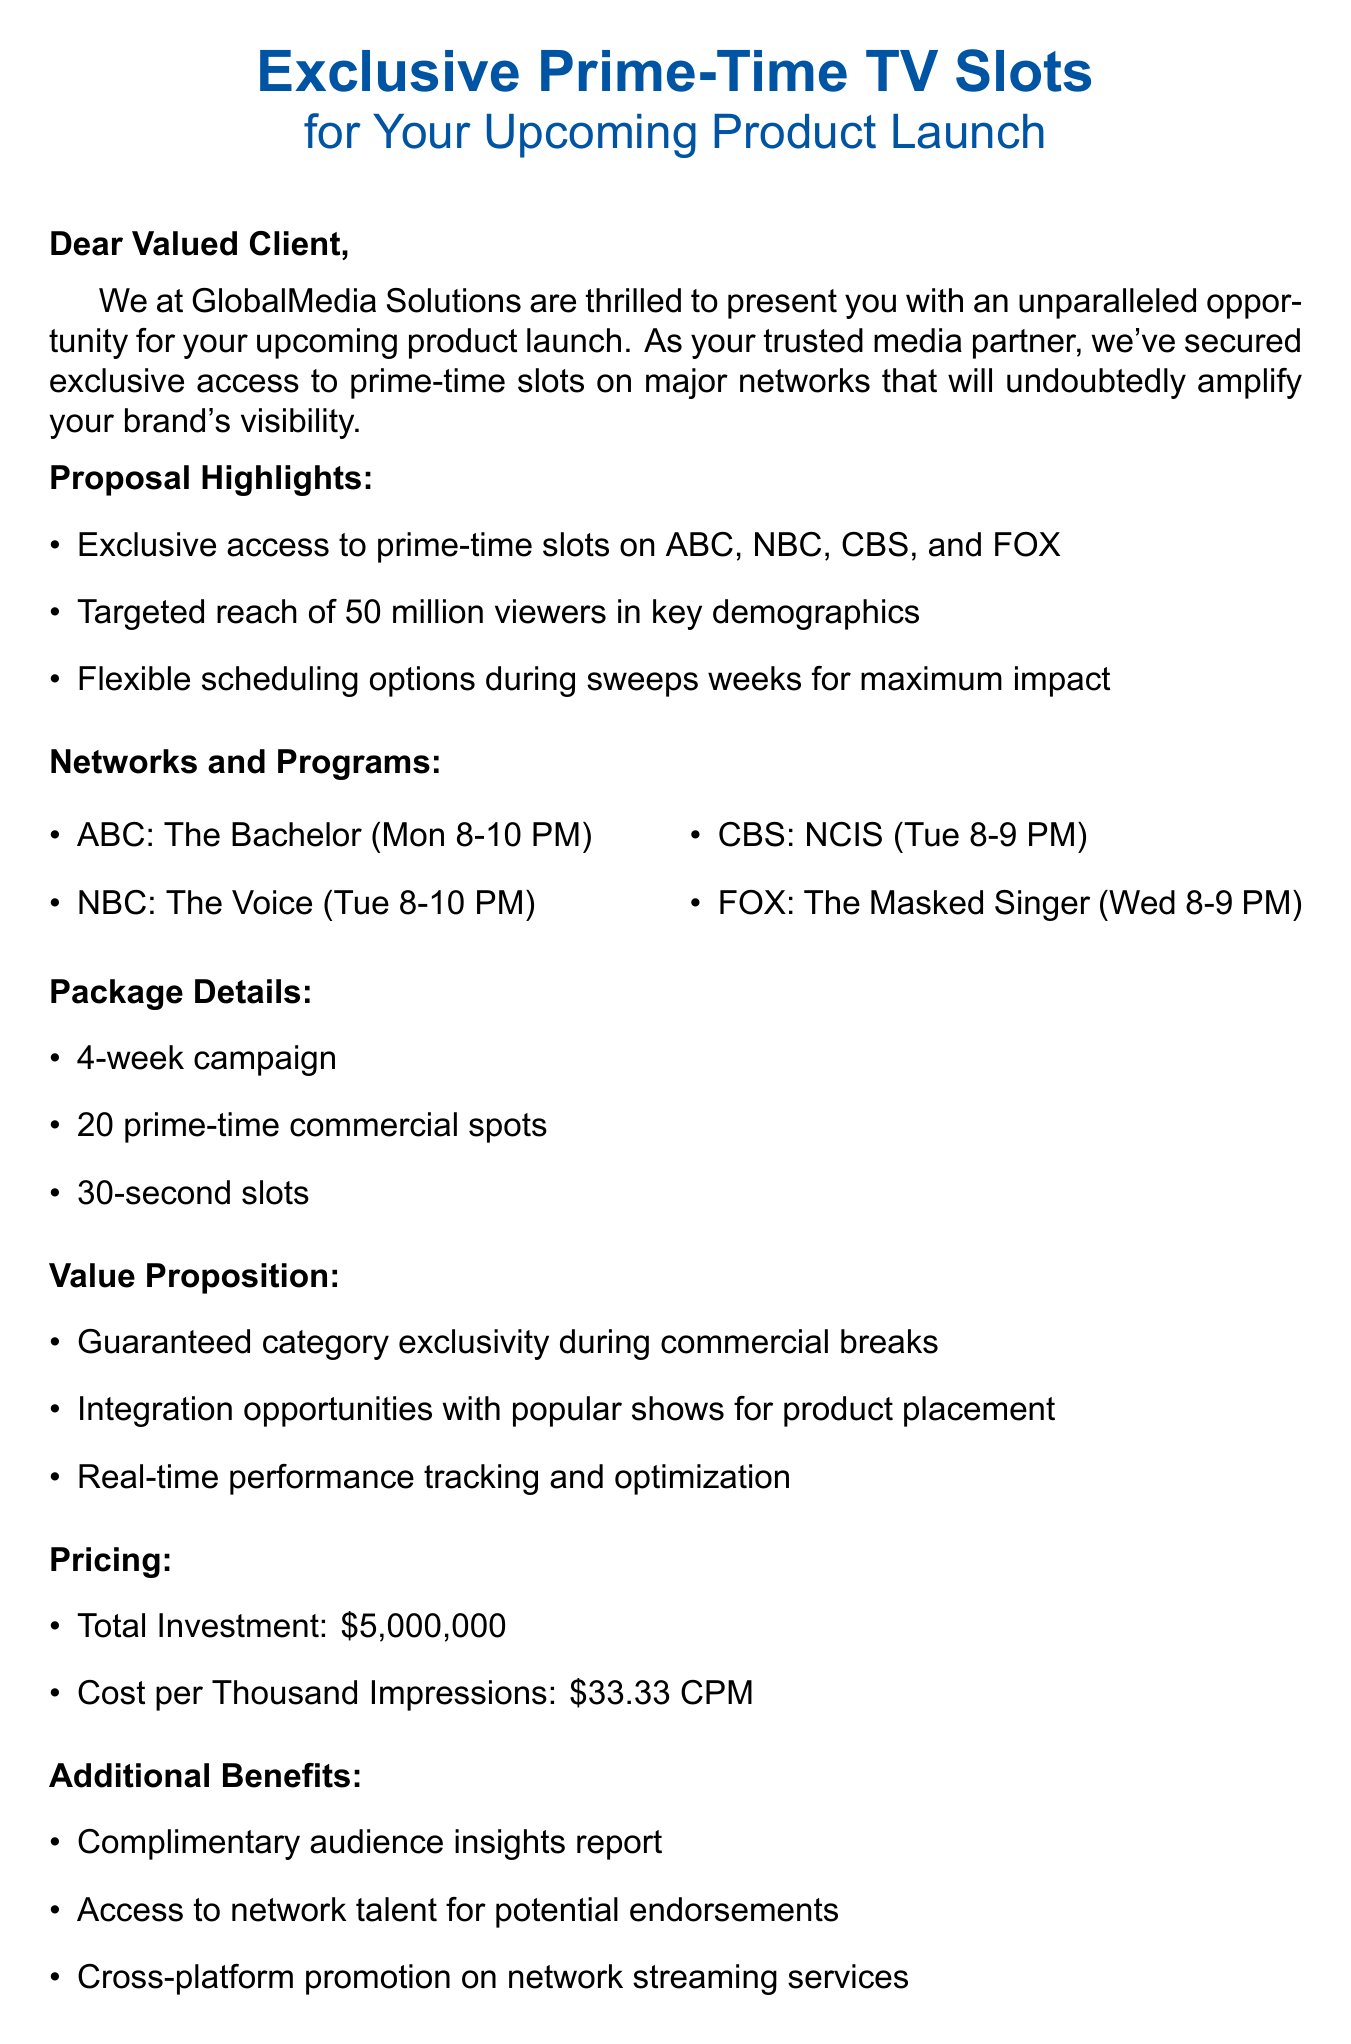What is the total investment? The total investment is stated in the pricing section of the document, which is $5,000,000.
Answer: $5,000,000 How many commercial spots are included in the package? The package details specify the total number of commercial spots, which is 20.
Answer: 20 Which network features "The Bachelor"? The networks and programs section lists the programs along with their respective networks, where "The Bachelor" is on ABC.
Answer: ABC What is the duration of the campaign? The package details mention that the duration of the campaign is 4 weeks.
Answer: 4-week campaign What is the cost per thousand impressions (CPM)? The pricing section provides the cost per thousand impressions, which is $33.33 CPM.
Answer: $33.33 CPM What type of report is included as an additional benefit? The additional benefits section mentions a complimentary audience insights report.
Answer: Complimentary audience insights report Which program airs on NBC? The networks and programs section states that "The Voice" airs on NBC.
Answer: The Voice How many prime-time networks are mentioned in the proposal? The proposal highlights indicate that there are four major networks mentioned: ABC, NBC, CBS, and FOX.
Answer: Four What is the call to action in the email? The conclusion of the email contains the call to action, which is to schedule a meeting to secure exclusive slots.
Answer: Schedule a meeting to secure these exclusive slots before they're gone 